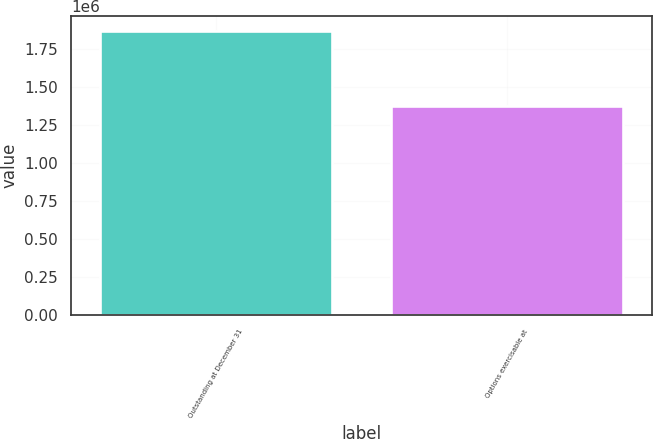<chart> <loc_0><loc_0><loc_500><loc_500><bar_chart><fcel>Outstanding at December 31<fcel>Options exercisable at<nl><fcel>1.87169e+06<fcel>1.37792e+06<nl></chart> 